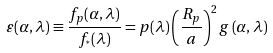<formula> <loc_0><loc_0><loc_500><loc_500>\varepsilon ( \alpha , \lambda ) \equiv \frac { f _ { p } ( \alpha , \lambda ) } { f _ { ^ { * } } ( \lambda ) } = p ( \lambda ) \left ( \frac { R _ { p } } { a } \right ) ^ { 2 } g \left ( \alpha , \lambda \right )</formula> 